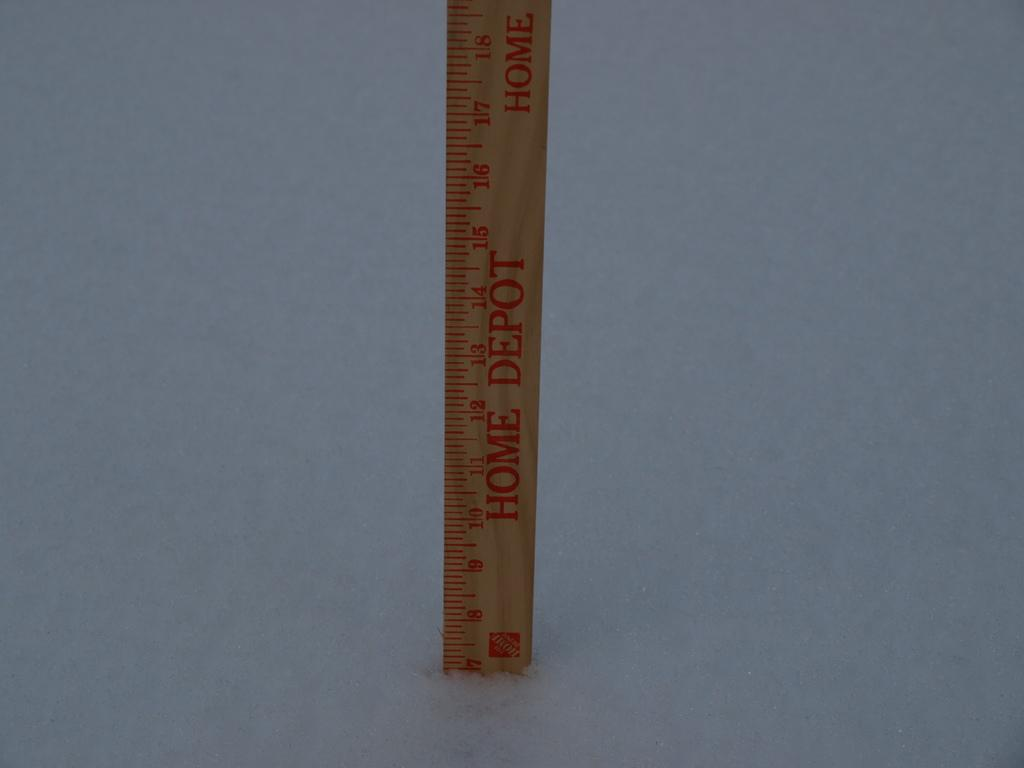<image>
Summarize the visual content of the image. A home depot ruler sits on one end. 